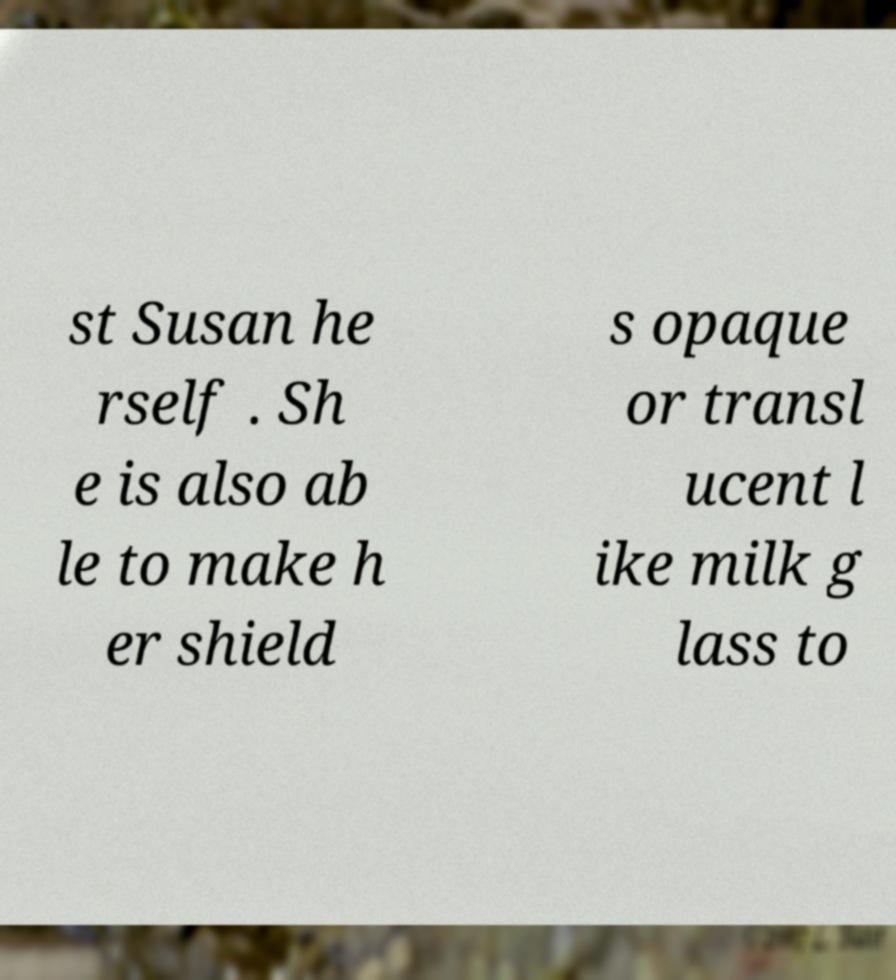There's text embedded in this image that I need extracted. Can you transcribe it verbatim? st Susan he rself . Sh e is also ab le to make h er shield s opaque or transl ucent l ike milk g lass to 